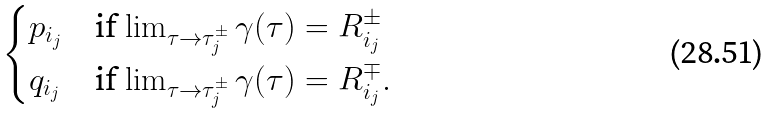<formula> <loc_0><loc_0><loc_500><loc_500>\begin{cases} p _ { i _ { j } } & \text {if $\lim_{\tau\to \tau_{j}^{\pm}} \gamma(\tau) = R_{i_{j}}^{\pm}$} \\ q _ { i _ { j } } & \text {if $\lim_{\tau\to \tau_{j}^{\pm}} \gamma(\tau) = R_{i_{j}}^{\mp}$} . \end{cases}</formula> 